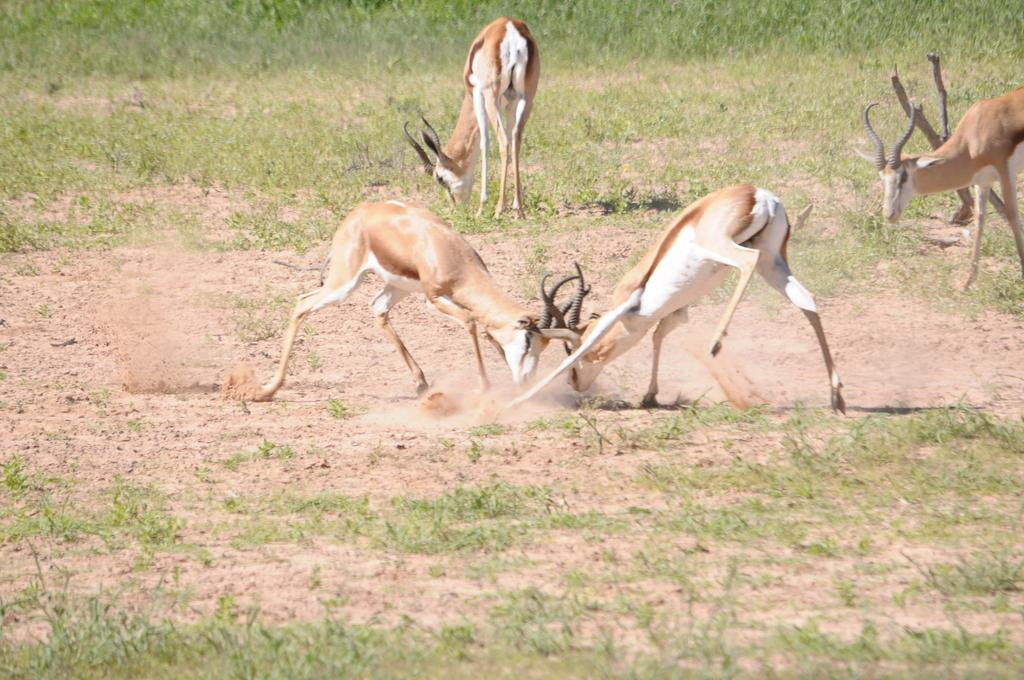What types of living organisms can be seen in the image? There are animals in the image. What type of terrain is visible in the image? There is sand and grass in the image. What type of note is being sung by the animals in the image? There are no animals singing in the image, and therefore no note can be heard. 